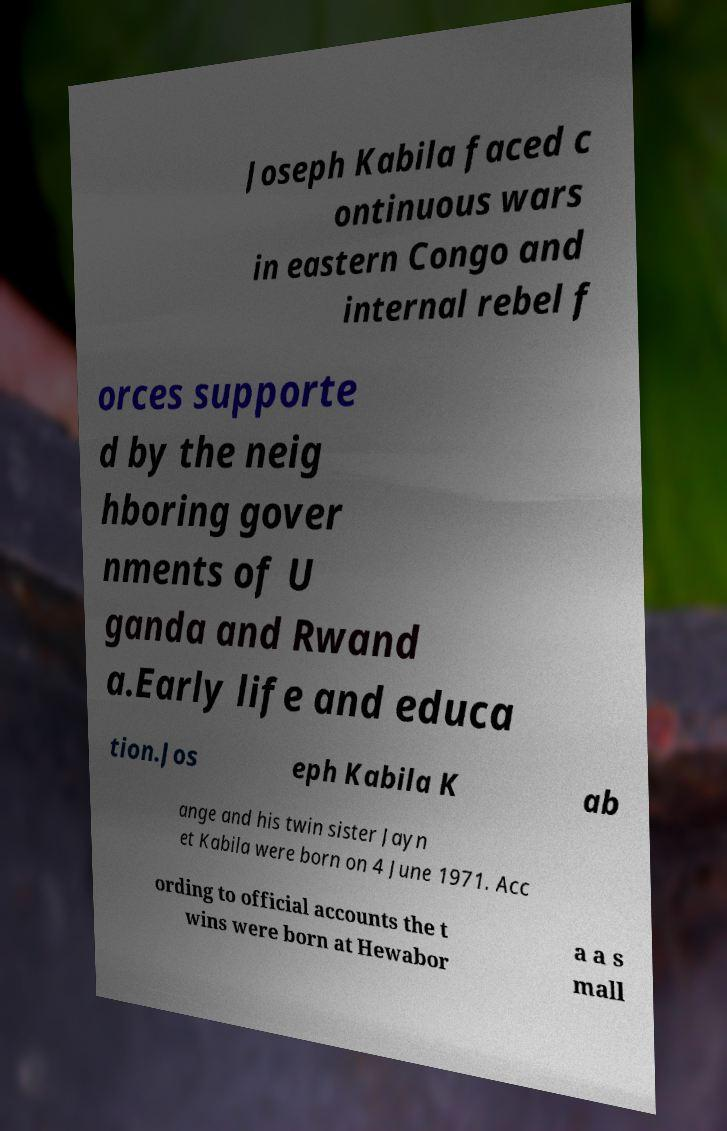Can you read and provide the text displayed in the image?This photo seems to have some interesting text. Can you extract and type it out for me? Joseph Kabila faced c ontinuous wars in eastern Congo and internal rebel f orces supporte d by the neig hboring gover nments of U ganda and Rwand a.Early life and educa tion.Jos eph Kabila K ab ange and his twin sister Jayn et Kabila were born on 4 June 1971. Acc ording to official accounts the t wins were born at Hewabor a a s mall 